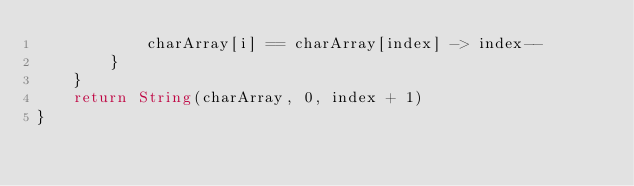Convert code to text. <code><loc_0><loc_0><loc_500><loc_500><_Kotlin_>            charArray[i] == charArray[index] -> index--
        }
    }
    return String(charArray, 0, index + 1)
}</code> 